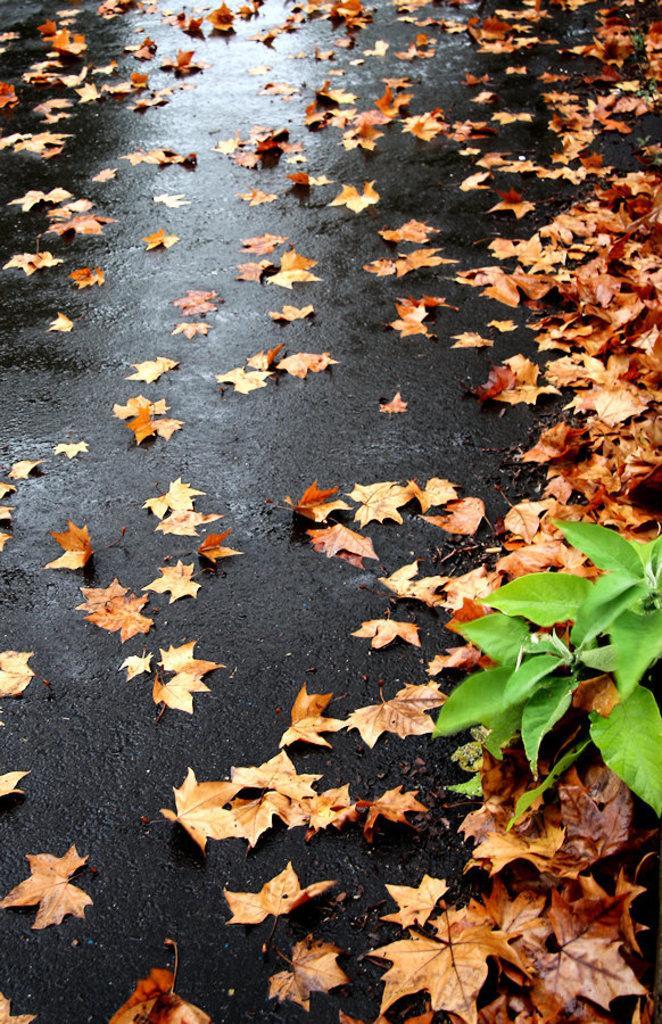In one or two sentences, can you explain what this image depicts? In this image we can see the wet road, some maple leaves on the road and some green leaves with stems on the right side of the image. 